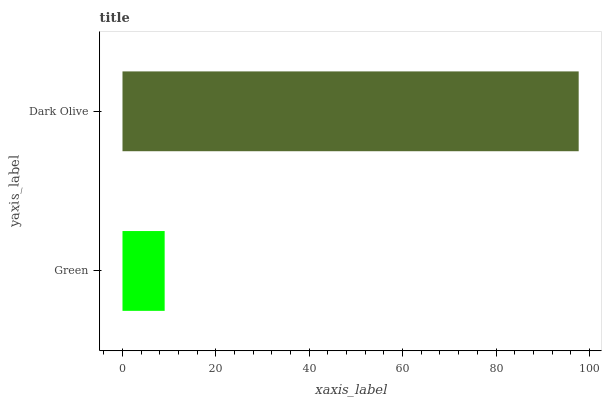Is Green the minimum?
Answer yes or no. Yes. Is Dark Olive the maximum?
Answer yes or no. Yes. Is Dark Olive the minimum?
Answer yes or no. No. Is Dark Olive greater than Green?
Answer yes or no. Yes. Is Green less than Dark Olive?
Answer yes or no. Yes. Is Green greater than Dark Olive?
Answer yes or no. No. Is Dark Olive less than Green?
Answer yes or no. No. Is Dark Olive the high median?
Answer yes or no. Yes. Is Green the low median?
Answer yes or no. Yes. Is Green the high median?
Answer yes or no. No. Is Dark Olive the low median?
Answer yes or no. No. 